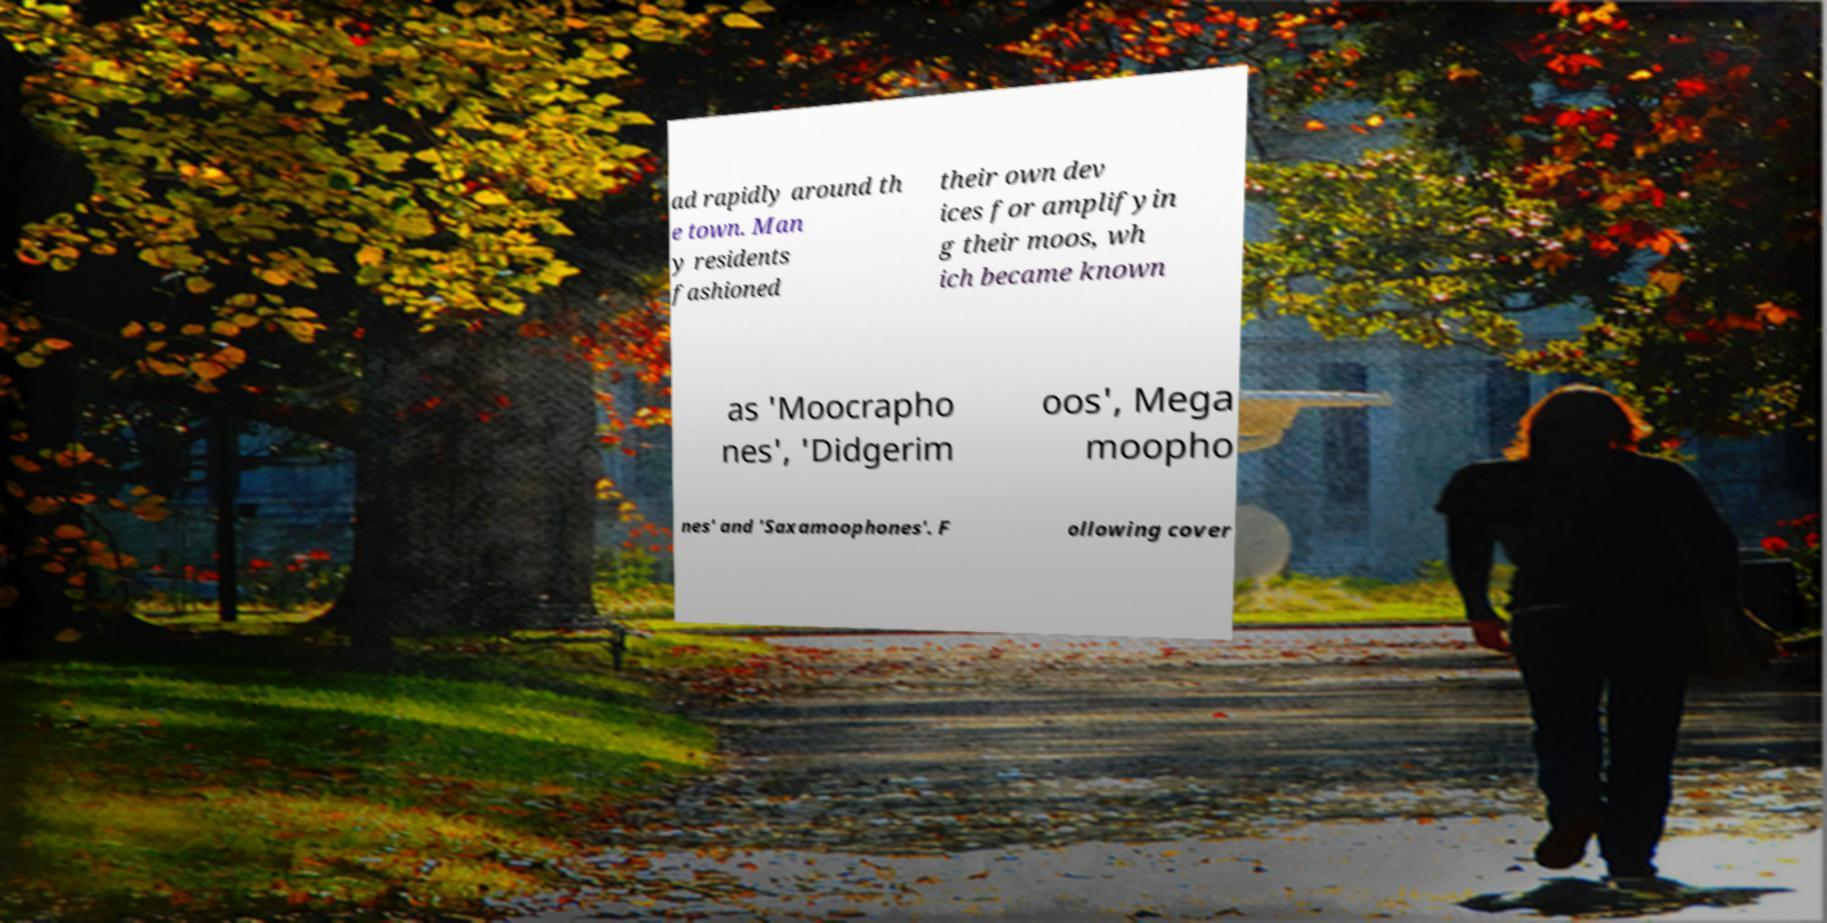There's text embedded in this image that I need extracted. Can you transcribe it verbatim? ad rapidly around th e town. Man y residents fashioned their own dev ices for amplifyin g their moos, wh ich became known as 'Moocrapho nes', 'Didgerim oos', Mega moopho nes' and 'Saxamoophones'. F ollowing cover 